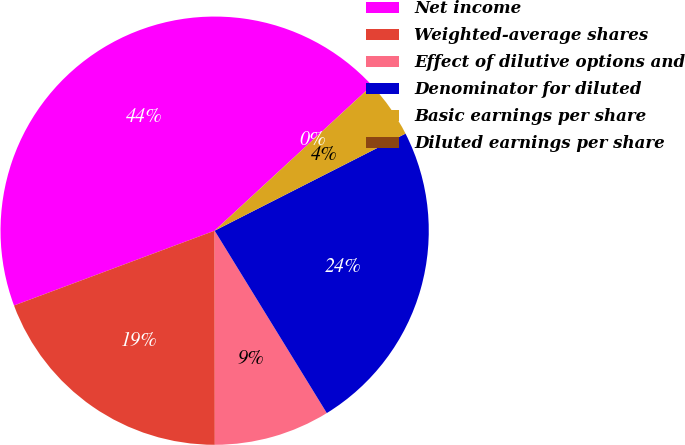<chart> <loc_0><loc_0><loc_500><loc_500><pie_chart><fcel>Net income<fcel>Weighted-average shares<fcel>Effect of dilutive options and<fcel>Denominator for diluted<fcel>Basic earnings per share<fcel>Diluted earnings per share<nl><fcel>43.81%<fcel>19.33%<fcel>8.76%<fcel>23.71%<fcel>4.38%<fcel>0.0%<nl></chart> 